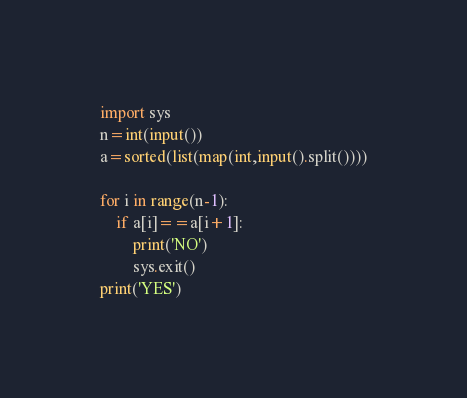<code> <loc_0><loc_0><loc_500><loc_500><_Python_>import sys
n=int(input())
a=sorted(list(map(int,input().split())))

for i in range(n-1):
    if a[i]==a[i+1]:
        print('NO')
        sys.exit()
print('YES')</code> 